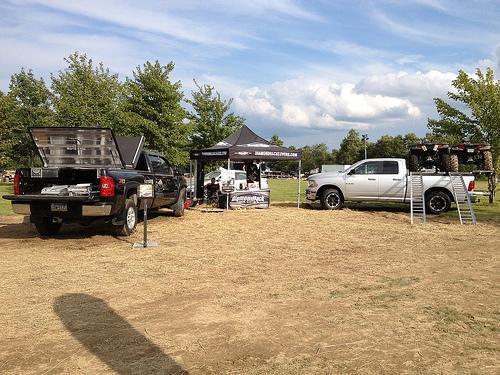How many trucks?
Give a very brief answer. 2. How many ATV's are there?
Give a very brief answer. 2. How many vehicles have their top popped?
Give a very brief answer. 1. 